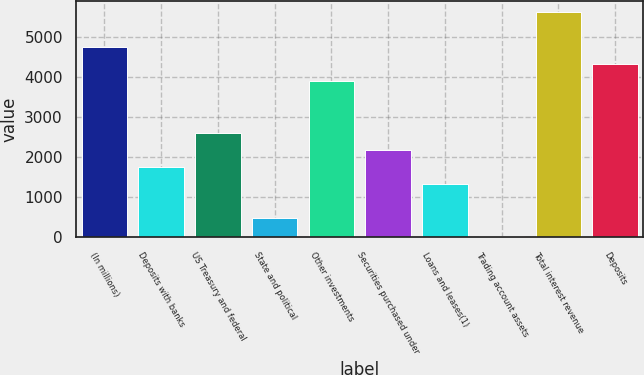<chart> <loc_0><loc_0><loc_500><loc_500><bar_chart><fcel>(In millions)<fcel>Deposits with banks<fcel>US Treasury and federal<fcel>State and political<fcel>Other investments<fcel>Securities purchased under<fcel>Loans and leases(1)<fcel>Trading account assets<fcel>Total interest revenue<fcel>Deposits<nl><fcel>4751.6<fcel>1758.4<fcel>2613.6<fcel>475.6<fcel>3896.4<fcel>2186<fcel>1330.8<fcel>48<fcel>5606.8<fcel>4324<nl></chart> 